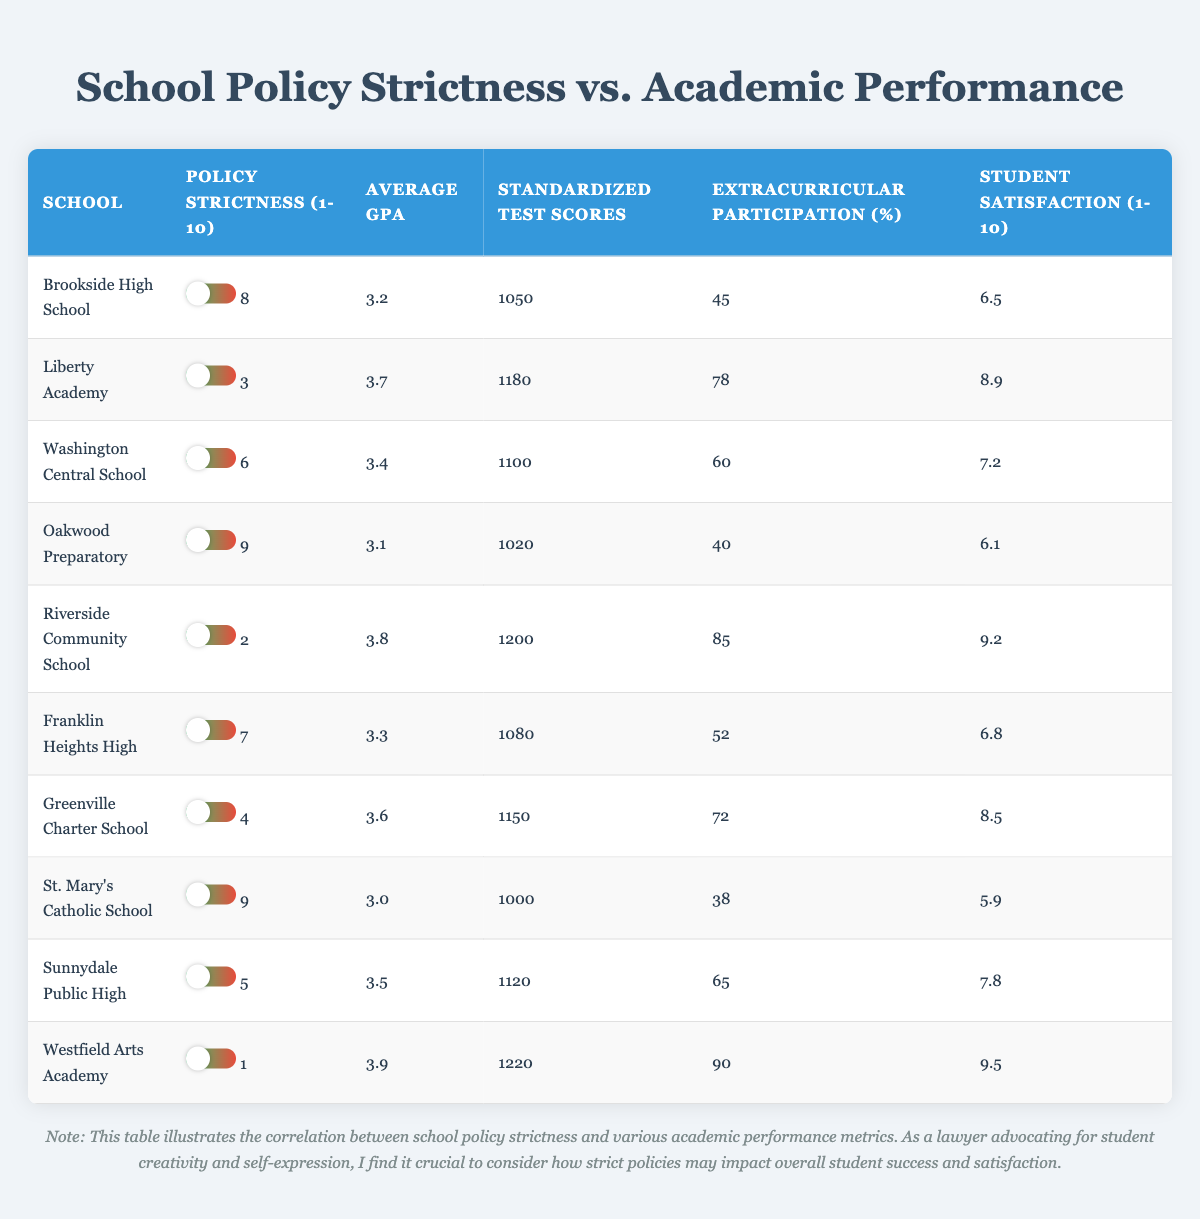What is the average GPA of schools with a policy strictness rating of 1? From the table, there is only one school with a policy strictness rating of 1, which is Westfield Arts Academy with a GPA of 3.9. Thus, the average GPA for this group is 3.9.
Answer: 3.9 Which school has the highest standardized test score? Looking at the standardized test scores, Riverside Community School has the highest score of 1200.
Answer: Riverside Community School Is the statement "Students at schools with higher policy strictness generally have lower GPAs" true? By comparing the data, we can observe that as policy strictness increases, the average GPAs of the schools decrease (e.g., Oakwood Preparatory has a policy strictness of 9 and a GPA of 3.1, while Riverside Community School has a policy strictness of 2 and a GPA of 3.8). This indicates a negative correlation between policy strictness and GPA.
Answer: Yes What is the difference in average GPA between schools with policy strictness of 9 and those with policy strictness of 2? The average GPA of schools with a strictness of 9 (Oakwood Preparatory and St. Mary's Catholic School) is (3.1 + 3.0)/2 = 3.05. The average GPA for schools with a strictness of 2, represented by Riverside Community School, is 3.8. The difference in GPA is 3.8 - 3.05 = 0.75.
Answer: 0.75 How many schools have an average GPA above 3.5? Checking the table, the schools with average GPAs above 3.5 are Liberty Academy (3.7), Riverside Community School (3.8), and Westfield Arts Academy (3.9). Therefore, there are 3 schools that meet this criterion.
Answer: 3 What is the mean student satisfaction of schools with policy strictness ratings between 6 and 8? The schools with ratings of 6, 7, and 8 are Washington Central School (7.2), Franklin Heights High (6.8), and Brookside High School (6.5). The mean satisfaction is (7.2 + 6.8 + 6.5) / 3 = 6.8333.
Answer: 6.83 Is there a school that ranks in the top 2 for both extracurricular participation and student satisfaction? By examining the data, Riverside Community School has a high extracurricular participation rate of 85% and the highest satisfaction rating of 9.2. No other school matches these high ranks simultaneously.
Answer: Yes What is the total number of extracurricular participation percentage points from schools with policy strictness of 4 and above? The schools with a policy strictness of 4 and above are Brookside High School (45), Washington Central School (60), Franklin Heights High (52), Oakwood Preparatory (40), and St. Mary's Catholic School (38). Adding these gives 45 + 60 + 52 + 40 + 38 = 235.
Answer: 235 